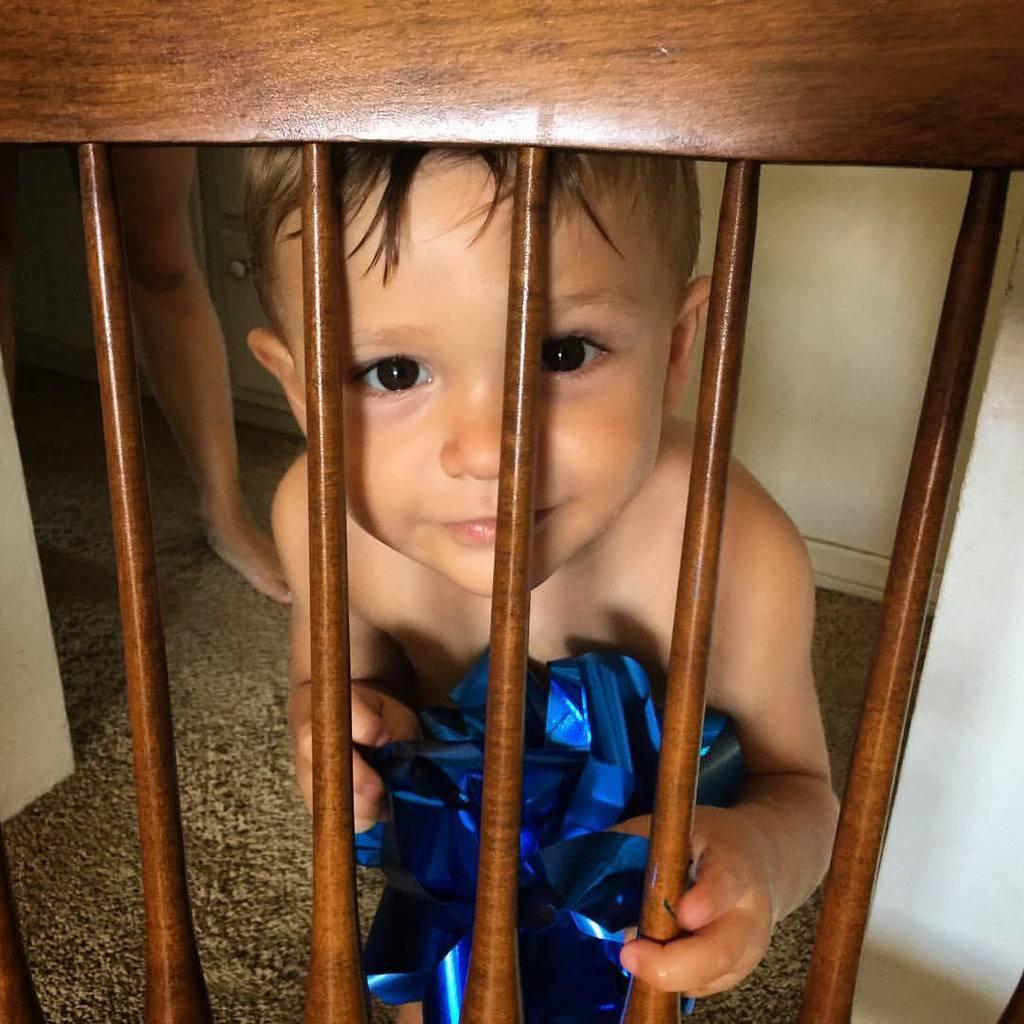Who is present in the image? There is a boy in the image. What is the boy's expression? The boy is smiling. What objects can be seen in the image? There are wooden rods in the image. What is visible in the background of the image? There is a wall in the background of the image. What type of bells can be heard ringing in the image? There are no bells present in the image, and therefore no sound can be heard. What type of destruction is visible in the image? There is no destruction present in the image; it features a smiling boy and wooden rods. 